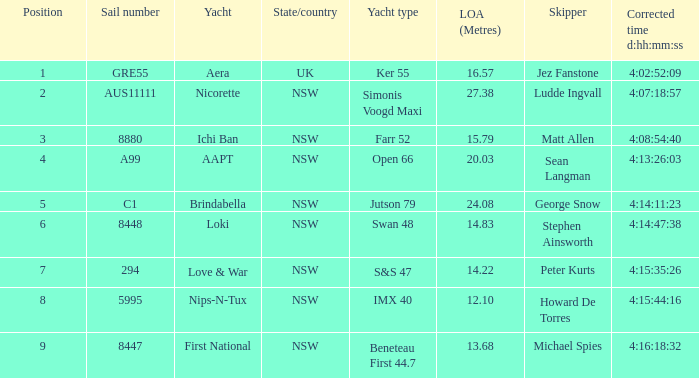What is the overall length of sail for the boat with a correct time of 4:15:35:26? 14.22. Can you give me this table as a dict? {'header': ['Position', 'Sail number', 'Yacht', 'State/country', 'Yacht type', 'LOA (Metres)', 'Skipper', 'Corrected time d:hh:mm:ss'], 'rows': [['1', 'GRE55', 'Aera', 'UK', 'Ker 55', '16.57', 'Jez Fanstone', '4:02:52:09'], ['2', 'AUS11111', 'Nicorette', 'NSW', 'Simonis Voogd Maxi', '27.38', 'Ludde Ingvall', '4:07:18:57'], ['3', '8880', 'Ichi Ban', 'NSW', 'Farr 52', '15.79', 'Matt Allen', '4:08:54:40'], ['4', 'A99', 'AAPT', 'NSW', 'Open 66', '20.03', 'Sean Langman', '4:13:26:03'], ['5', 'C1', 'Brindabella', 'NSW', 'Jutson 79', '24.08', 'George Snow', '4:14:11:23'], ['6', '8448', 'Loki', 'NSW', 'Swan 48', '14.83', 'Stephen Ainsworth', '4:14:47:38'], ['7', '294', 'Love & War', 'NSW', 'S&S 47', '14.22', 'Peter Kurts', '4:15:35:26'], ['8', '5995', 'Nips-N-Tux', 'NSW', 'IMX 40', '12.10', 'Howard De Torres', '4:15:44:16'], ['9', '8447', 'First National', 'NSW', 'Beneteau First 44.7', '13.68', 'Michael Spies', '4:16:18:32']]} 